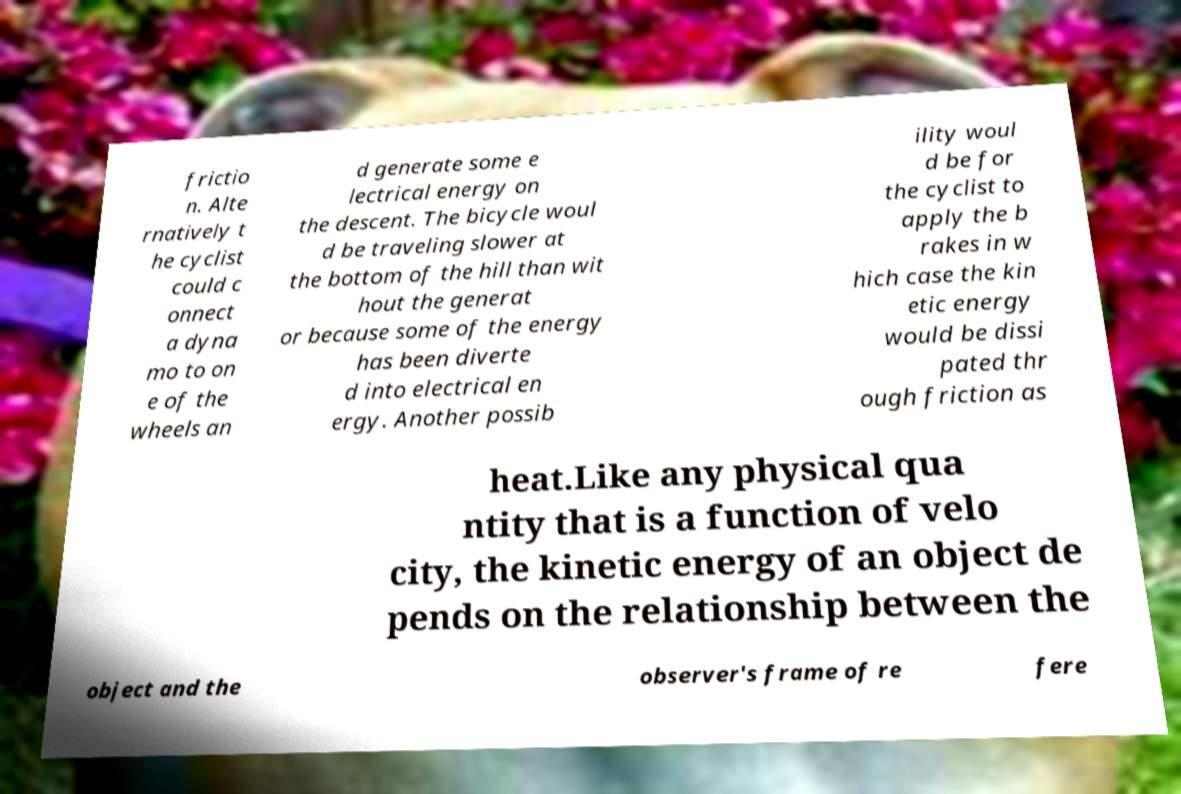I need the written content from this picture converted into text. Can you do that? frictio n. Alte rnatively t he cyclist could c onnect a dyna mo to on e of the wheels an d generate some e lectrical energy on the descent. The bicycle woul d be traveling slower at the bottom of the hill than wit hout the generat or because some of the energy has been diverte d into electrical en ergy. Another possib ility woul d be for the cyclist to apply the b rakes in w hich case the kin etic energy would be dissi pated thr ough friction as heat.Like any physical qua ntity that is a function of velo city, the kinetic energy of an object de pends on the relationship between the object and the observer's frame of re fere 